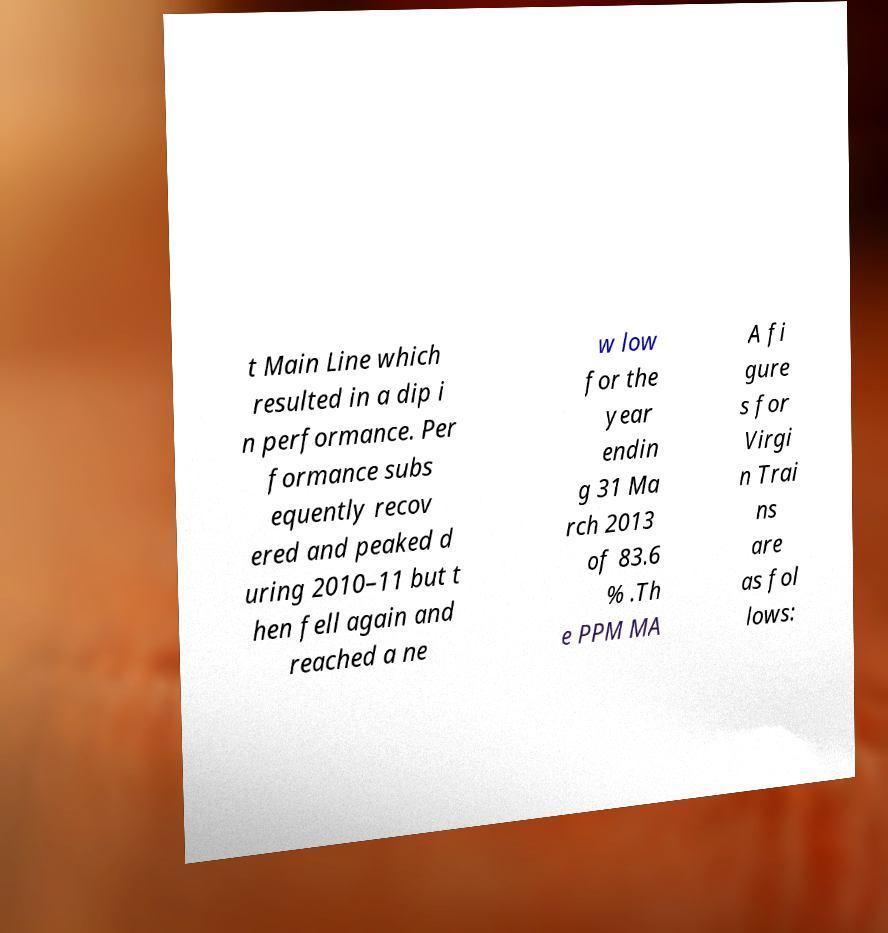Could you assist in decoding the text presented in this image and type it out clearly? t Main Line which resulted in a dip i n performance. Per formance subs equently recov ered and peaked d uring 2010–11 but t hen fell again and reached a ne w low for the year endin g 31 Ma rch 2013 of 83.6 % .Th e PPM MA A fi gure s for Virgi n Trai ns are as fol lows: 